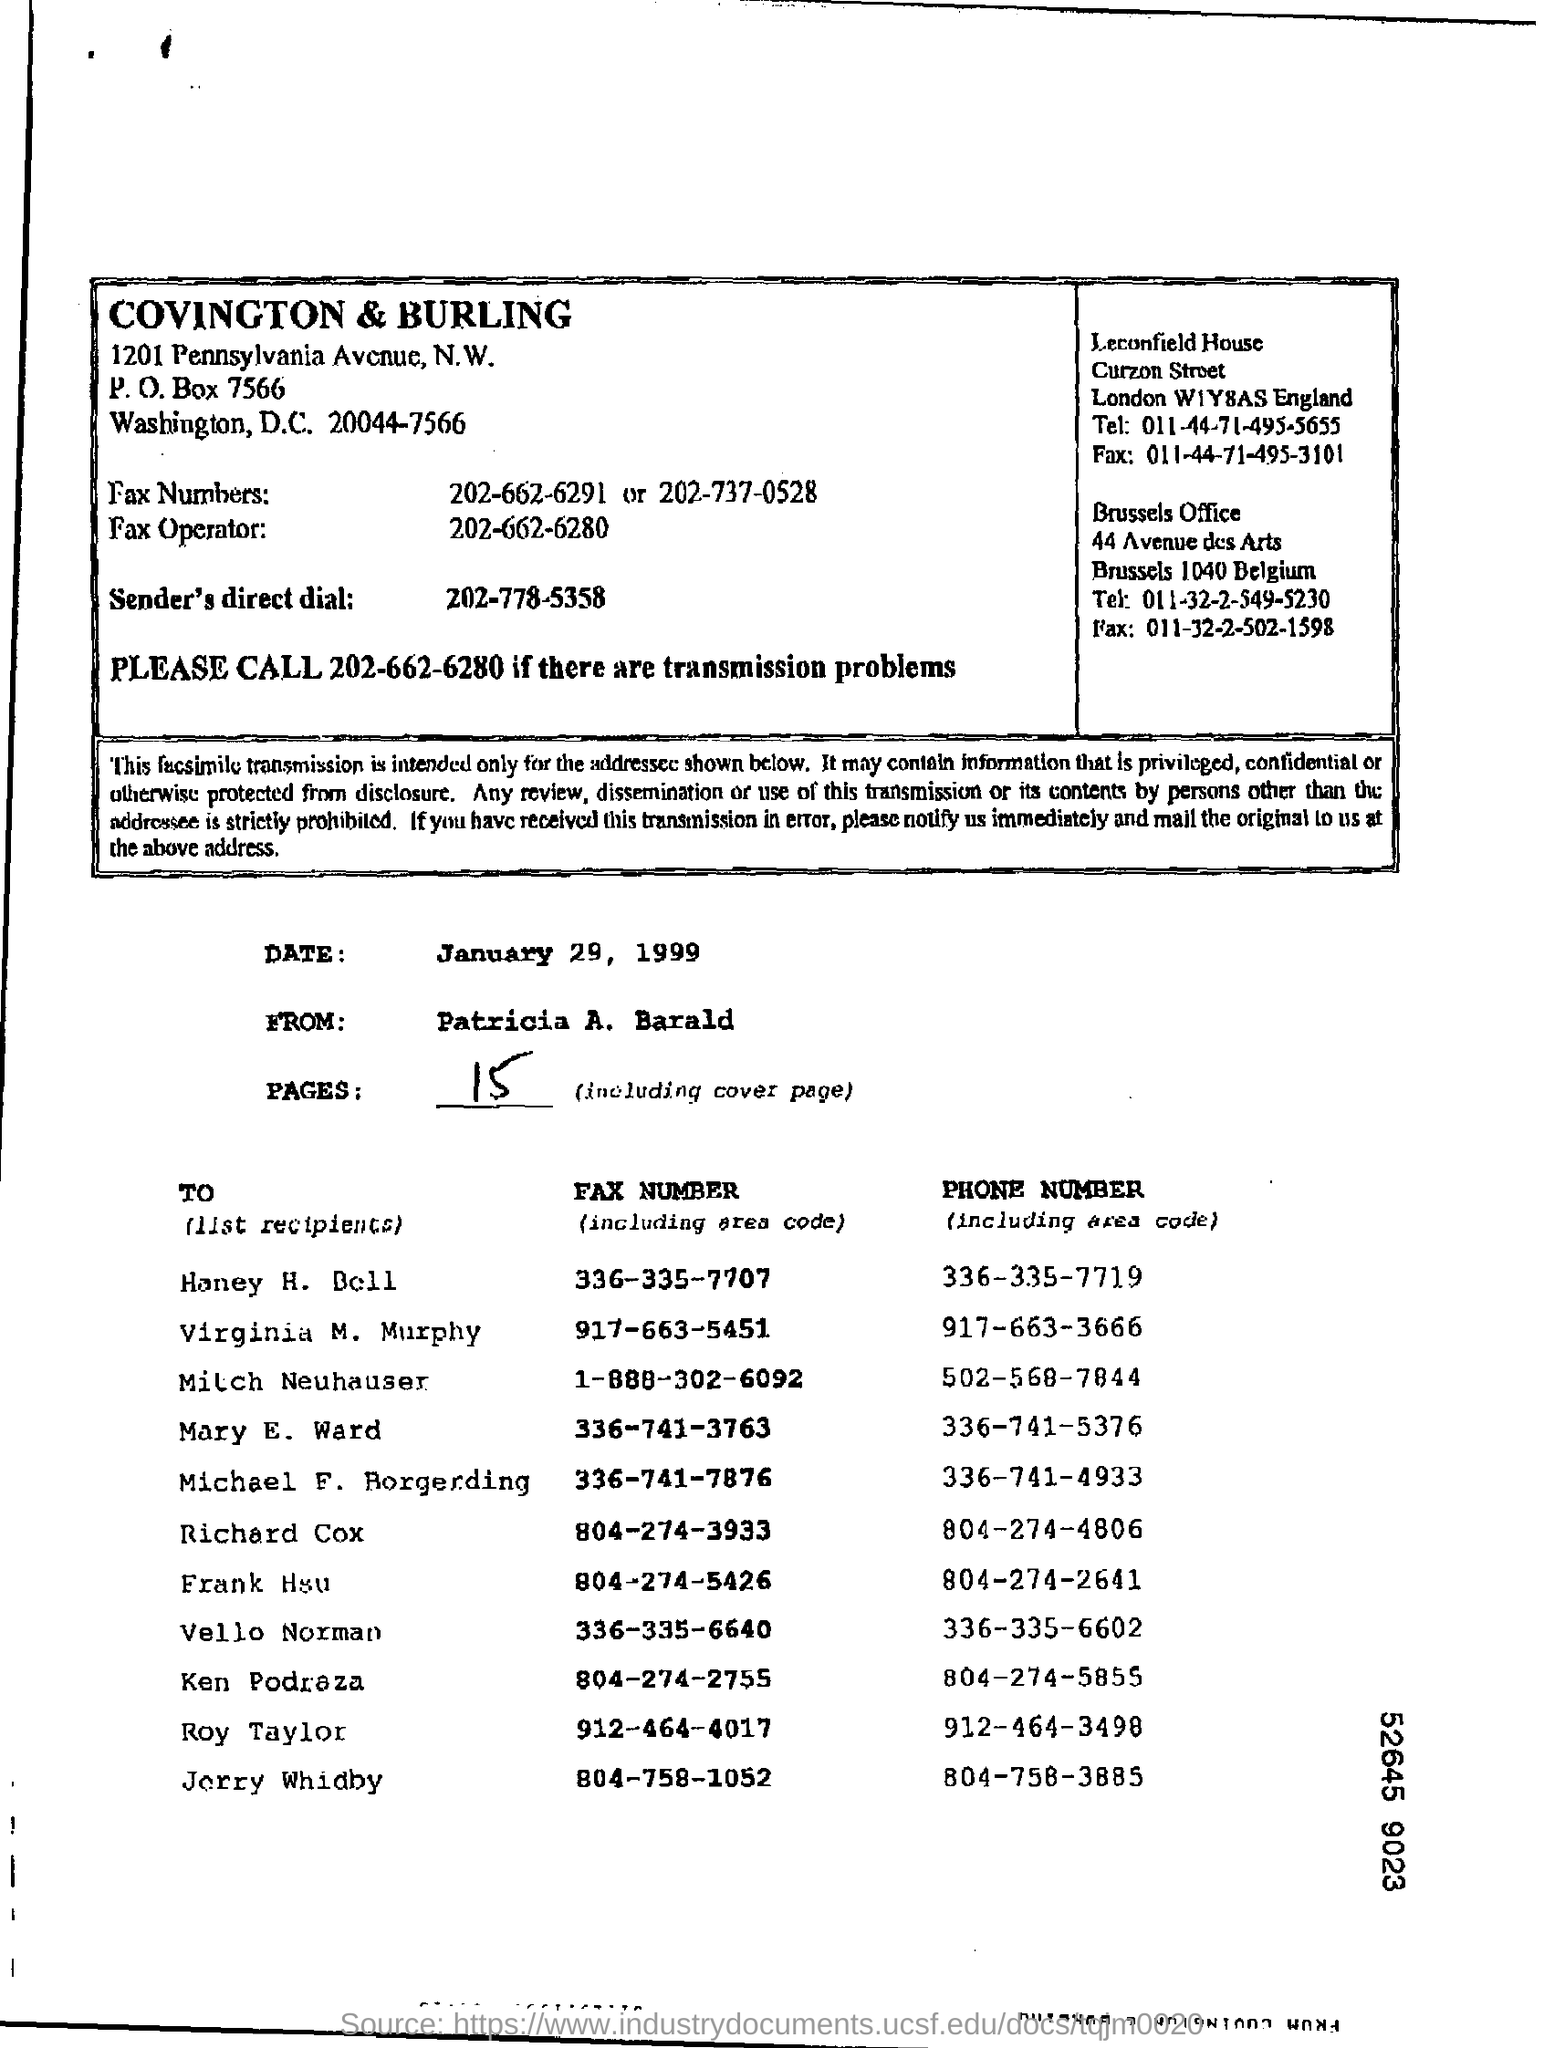Give some essential details in this illustration. The date mentioned in the document is January 29, 1999. The fax is sent by Patricia A. Barald. The phone number of Mary E. Ward is 336-741-5376. The fax number of Richard Cox is 804-274-3933. The P.O Box Number is 7566. 